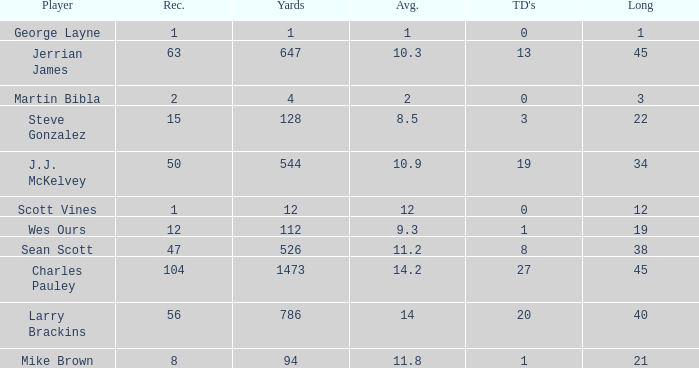What is the average for wes ours with over 1 reception and under 1 TD? None. 